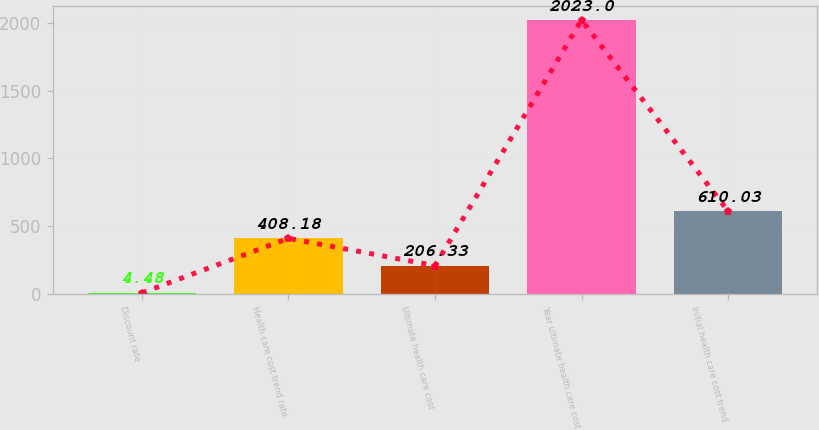<chart> <loc_0><loc_0><loc_500><loc_500><bar_chart><fcel>Discount rate<fcel>Health care cost trend rate<fcel>Ultimate health care cost<fcel>Year ultimate health care cost<fcel>Initial health care cost trend<nl><fcel>4.48<fcel>408.18<fcel>206.33<fcel>2023<fcel>610.03<nl></chart> 